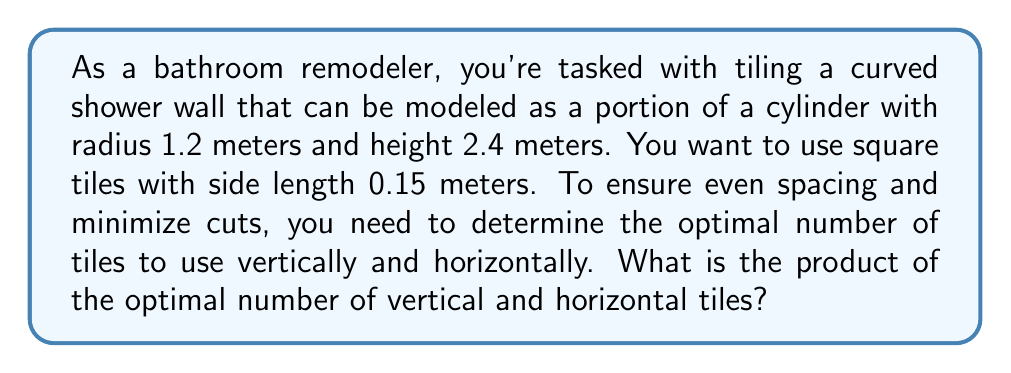Provide a solution to this math problem. Let's approach this problem step-by-step:

1) First, we need to calculate the surface area of the cylindrical shower wall:
   The surface area of a cylinder (excluding top and bottom) is given by $2\pi rh$, where $r$ is the radius and $h$ is the height.
   
   Surface area $= 2\pi \cdot 1.2 \cdot 2.4 = 18.09557$ m²

2) Now, we need to determine the number of tiles that fit vertically:
   Vertical tiles $= \frac{\text{Height}}{\text{Tile size}} = \frac{2.4}{0.15} = 16$

3) For the horizontal direction, we need to calculate the circumference of the cylinder:
   Circumference $= 2\pi r = 2\pi \cdot 1.2 = 7.539822$ m

4) To find the optimal number of horizontal tiles, we divide the circumference by the tile size and round to the nearest whole number:
   Horizontal tiles $= \text{round}(\frac{7.539822}{0.15}) = \text{round}(50.26548) = 50$

5) The product of vertical and horizontal tiles is:
   $16 \cdot 50 = 800$

This arrangement will ensure even spacing and minimize the need for cuts. Any small discrepancies can be accounted for in the grout lines.
Answer: 800 